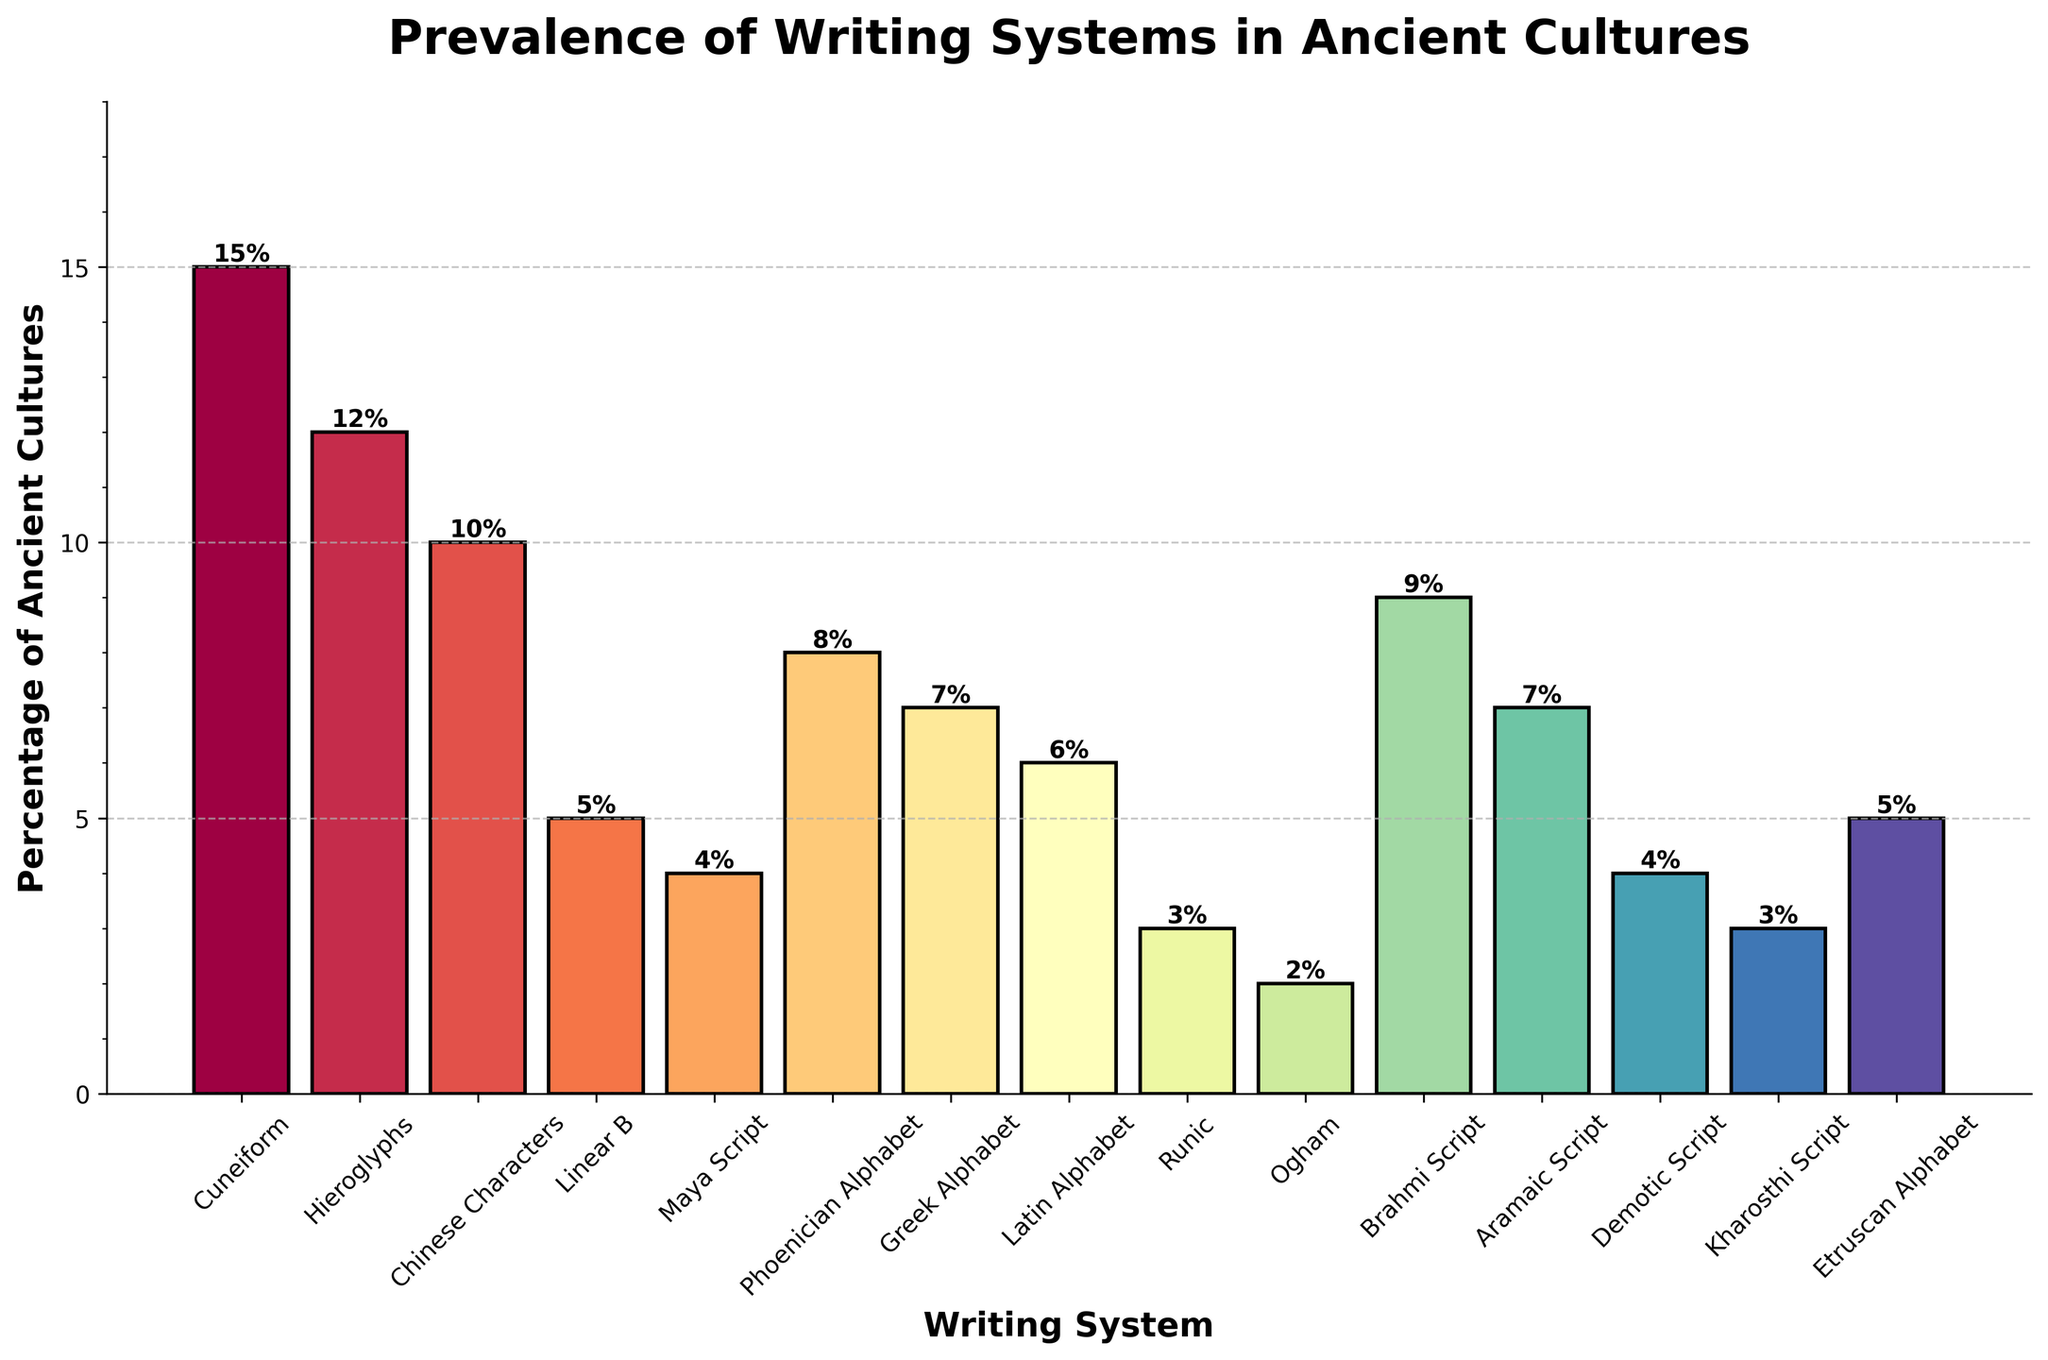Which writing system has the highest prevalence in ancient cultures? The bar chart shows the prevalence percentage of different writing systems among ancient cultures. The tallest bar indicates the Cuneiform writing system at 15%.
Answer: Cuneiform Which writing system is less prevalent, Maya Script or Ogham? By comparing the heights of the bars representing Maya Script and Ogham, the Maya Script has a higher bar at 4%, while Ogham is at 2%.
Answer: Ogham What is the total percentage of cultures that used Linear B, Etruscan Alphabet, and Runic writing systems? Refer to the bars for Linear B (5%), Etruscan Alphabet (5%), and Runic (3%). Summing them up: 5% + 5% + 3% = 13%.
Answer: 13% Which writing system is more prevalent, the Brahmi Script or the Aramaic Script? By looking at the bars for Brahmi Script (9%) and Aramaic Script (7%), the Brahmi Script has a higher percentage.
Answer: Brahmi Script How much higher is the prevalence of Cuneiform compared to Greek Alphabet? Cuneiform has a prevalence of 15%, while Greek Alphabet has 7%. The difference is 15% - 7% = 8%.
Answer: 8% What is the average prevalence of Chinese Characters, Phoenician Alphabet, and Kharosthi Script? Sum up the prevalences: Chinese Characters (10%), Phoenician Alphabet (8%), and Kharosthi Script (3%). 10% + 8% + 3% = 21%. Then, divide by the number of writing systems: 21% / 3 = 7%.
Answer: 7% Which writing system's bar is closest in color to Runic's bar visually? The Runic writing system's bar, colored by the Spectral colormap, appears in a specific gradient. Looking at other bars' colors, Demotic Script (4%) bar visually aligns closely in the color spectrum.
Answer: Demotic Script Among the listed writing systems, which one ranks fifth in terms of prevalence? Reviewing the prevalence percentages in descending order, fifth position is held by the Brahmi Script at 9%. The order is: Cuneiform, Hieroglyphs, Chinese Characters, Phoenician Alphabet, Brahmi Script.
Answer: Brahmi Script What is the combined prevalence of all writing systems with a percentage equal to or below 5%? List down the writing systems and their prevalences equal to or below 5%: Linear B (5%), Maya Script (4%), Runic (3%), Ogham (2%), Demotic Script (4%), Kharosthi Script (3%), Etruscan Alphabet (5%). Sum these: 5% + 4% + 3% + 2% + 4% + 3% + 5% = 26%.
Answer: 26% 